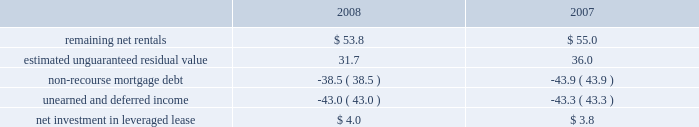Kimco realty corporation and subsidiaries notes to consolidated financial statements , continued investment in retail store leases the company has interests in various retail store leases relating to the anchor store premises in neighborhood and community shopping centers .
These premises have been sublet to retailers who lease the stores pursuant to net lease agreements .
Income from the investment in these retail store leases during the years ended december 31 , 2008 , 2007 and 2006 , was approximately $ 2.7 million , $ 1.2 million and $ 1.3 million , respectively .
These amounts represent sublease revenues during the years ended december 31 , 2008 , 2007 and 2006 , of approximately $ 7.1 million , $ 7.7 million and $ 8.2 million , respectively , less related expenses of $ 4.4 million , $ 5.1 million and $ 5.7 million , respectively , and an amount which , in management 2019s estimate , reasonably provides for the recovery of the investment over a period representing the expected remaining term of the retail store leases .
The company 2019s future minimum revenues under the terms of all non-cancelable tenant subleases and future minimum obligations through the remaining terms of its retail store leases , assuming no new or renegotiated leases are executed for such premises , for future years are as follows ( in millions ) : 2009 , $ 5.6 and $ 3.8 ; 2010 , $ 5.4 and $ 3.7 ; 2011 , $ 4.5 and $ 3.1 ; 2012 , $ 2.3 and $ 2.1 ; 2013 , $ 1.0 and $ 1.3 and thereafter , $ 1.4 and $ 0.5 , respectively .
Leveraged lease during june 2002 , the company acquired a 90% ( 90 % ) equity participation interest in an existing leveraged lease of 30 properties .
The properties are leased under a long-term bond-type net lease whose primary term expires in 2016 , with the lessee having certain renewal option rights .
The company 2019s cash equity investment was approximately $ 4.0 million .
This equity investment is reported as a net investment in leveraged lease in accordance with sfas no .
13 , accounting for leases ( as amended ) .
From 2002 to 2007 , 18 of these properties were sold , whereby the proceeds from the sales were used to pay down the mortgage debt by approximately $ 31.2 million .
As of december 31 , 2008 , the remaining 12 properties were encumbered by third-party non-recourse debt of approximately $ 42.8 million that is scheduled to fully amortize during the primary term of the lease from a portion of the periodic net rents receivable under the net lease .
As an equity participant in the leveraged lease , the company has no recourse obligation for principal or interest payments on the debt , which is collateralized by a first mortgage lien on the properties and collateral assignment of the lease .
Accordingly , this obligation has been offset against the related net rental receivable under the lease .
At december 31 , 2008 and 2007 , the company 2019s net investment in the leveraged lease consisted of the following ( in millions ) : .
Mortgages and other financing receivables : the company has various mortgages and other financing receivables which consist of loans acquired and loans originated by the company .
For a complete listing of the company 2019s mortgages and other financing receivables at december 31 , 2008 , see financial statement schedule iv included on page 141 of this annual report on form 10-k .
Reconciliation of mortgage loans and other financing receivables on real estate: .
What is the total of the company 2019s future minimum revenues under the terms of all non-cancelable tenant sublease from 2009-2011 , in millions?\\n? 
Computations: ((5.6 + 5.4) + 4.5)
Answer: 15.5. 